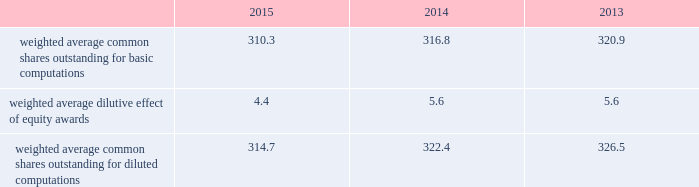2015 and 2014 was $ 1.5 billion and $ 1.3 billion .
The aggregate notional amount of our outstanding foreign currency hedges at december 31 , 2015 and 2014 was $ 4.1 billion and $ 804 million .
Derivative instruments did not have a material impact on net earnings and comprehensive income during 2015 , 2014 and 2013 .
Substantially all of our derivatives are designated for hedge accounting .
See note 16 for more information on the fair value measurements related to our derivative instruments .
Recent accounting pronouncements 2013 in may 2014 , the fasb issued a new standard that will change the way we recognize revenue and significantly expand the disclosure requirements for revenue arrangements .
On july 9 , 2015 , the fasb approved a one-year deferral of the effective date of the standard to 2018 for public companies , with an option that would permit companies to adopt the standard in 2017 .
Early adoption prior to 2017 is not permitted .
The new standard may be adopted either retrospectively or on a modified retrospective basis whereby the new standard would be applied to new contracts and existing contracts with remaining performance obligations as of the effective date , with a cumulative catch-up adjustment recorded to beginning retained earnings at the effective date for existing contracts with remaining performance obligations .
In addition , the fasb is contemplating making additional changes to certain elements of the new standard .
We are currently evaluating the methods of adoption allowed by the new standard and the effect the standard is expected to have on our consolidated financial statements and related disclosures .
As the new standard will supersede substantially all existing revenue guidance affecting us under gaap , it could impact revenue and cost recognition on thousands of contracts across all our business segments , in addition to our business processes and our information technology systems .
As a result , our evaluation of the effect of the new standard will extend over future periods .
In september 2015 , the fasb issued a new standard that simplifies the accounting for adjustments made to preliminary amounts recognized in a business combination by eliminating the requirement to retrospectively account for those adjustments .
Instead , adjustments will be recognized in the period in which the adjustments are determined , including the effect on earnings of any amounts that would have been recorded in previous periods if the accounting had been completed at the acquisition date .
We adopted the standard on january 1 , 2016 and will prospectively apply the standard to business combination adjustments identified after the date of adoption .
In november 2015 , the fasb issued a new standard that simplifies the presentation of deferred income taxes and requires that deferred tax assets and liabilities , as well as any related valuation allowance , be classified as noncurrent in our consolidated balance sheets .
The standard is effective january 1 , 2017 , with early adoption permitted .
The standard may be applied either prospectively from the date of adoption or retrospectively to all prior periods presented .
We are currently evaluating when we will adopt the standard and the method of adoption .
Note 2 2013 earnings per share the weighted average number of shares outstanding used to compute earnings per common share were as follows ( in millions ) : .
We compute basic and diluted earnings per common share by dividing net earnings by the respective weighted average number of common shares outstanding for the periods presented .
Our calculation of diluted earnings per common share also includes the dilutive effects for the assumed vesting of outstanding restricted stock units and exercise of outstanding stock options based on the treasury stock method .
The computation of diluted earnings per common share excluded 2.4 million stock options for the year ended december 31 , 2013 because their inclusion would have been anti-dilutive , primarily due to their exercise prices exceeding the average market prices of our common stock during the respective periods .
There were no anti-dilutive equity awards for the years ended december 31 , 2015 and 2014. .
What was the ratio of the amount of our outstanding foreign currency hedges in 2015 compared to 2014? 
Computations: (4.1 / 804)
Answer: 0.0051. 